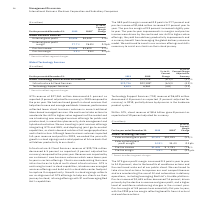According to International Business Machines's financial document, What caused the decrease in the pre-tax income in 2019? driven primarily by the decline in revenue and gross profit, and a higher level of workforce rebalancing charges in the current year.. The document states: "ax income of $1,645 million decreased 7.6 percent, driven primarily by the decline in revenue and gross profit, and a higher level of workforce rebala..." Also, What was the pre-tax margin of 2019? According to the financial document, 5.8%. The relevant text states: "Pre-tax margin 5.8% 5.9% (0.2)pts...." Also, What were the steps taken by the firm to improve the cost effectiveness? continued to take structural actions to improve our cost competitiveness and are accelerating the use of AI and automation in delivery operations, including leveraging Red Hat’s Ansible platform.. The document states: "nd the continued scale out of our public cloud. We continued to take structural actions to improve our cost competitiveness and are accelerating the u..." Also, can you calculate: What were the average External total gross profit? To answer this question, I need to perform calculations using the financial data. The calculation is: (9,515 + 10,035) / 2, which equals 9775 (in millions). This is based on the information: "External total gross profit $9,515 $10,035 (5.2)% External total gross profit $9,515 $10,035 (5.2)%..." The key data points involved are: 10,035, 9,515. Also, can you calculate: What was the increase / (decrease) rate in the Pre-tax income from 2018 to 2019? To answer this question, I need to perform calculations using the financial data. The calculation is: 1,645 / 1,781 - 1, which equals -7.64 (percentage). This is based on the information: "Pre-tax income $1,645 $ 1,781 (7.6)% Pre-tax income $1,645 $ 1,781 (7.6)%..." The key data points involved are: 1,645, 1,781. Also, can you calculate: What was the increase / (decrease) in the Pre-tax margin from 2018 to 2019? Based on the calculation: 5.8% - 5.9%, the result is -0.1 (percentage). This is based on the information: "Pre-tax margin 5.8% 5.9% (0.2)pts. Pre-tax margin 5.8% 5.9% (0.2)pts...." The key data points involved are: 5.8, 5.9. 